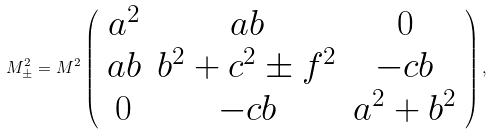Convert formula to latex. <formula><loc_0><loc_0><loc_500><loc_500>M _ { \pm } ^ { 2 } = M ^ { 2 } \left ( \begin{array} { c c c } a ^ { 2 } & a b & 0 \\ a b & b ^ { 2 } + c ^ { 2 } \pm f ^ { 2 } & - c b \\ 0 & - c b & a ^ { 2 } + b ^ { 2 } \end{array} \right ) ,</formula> 